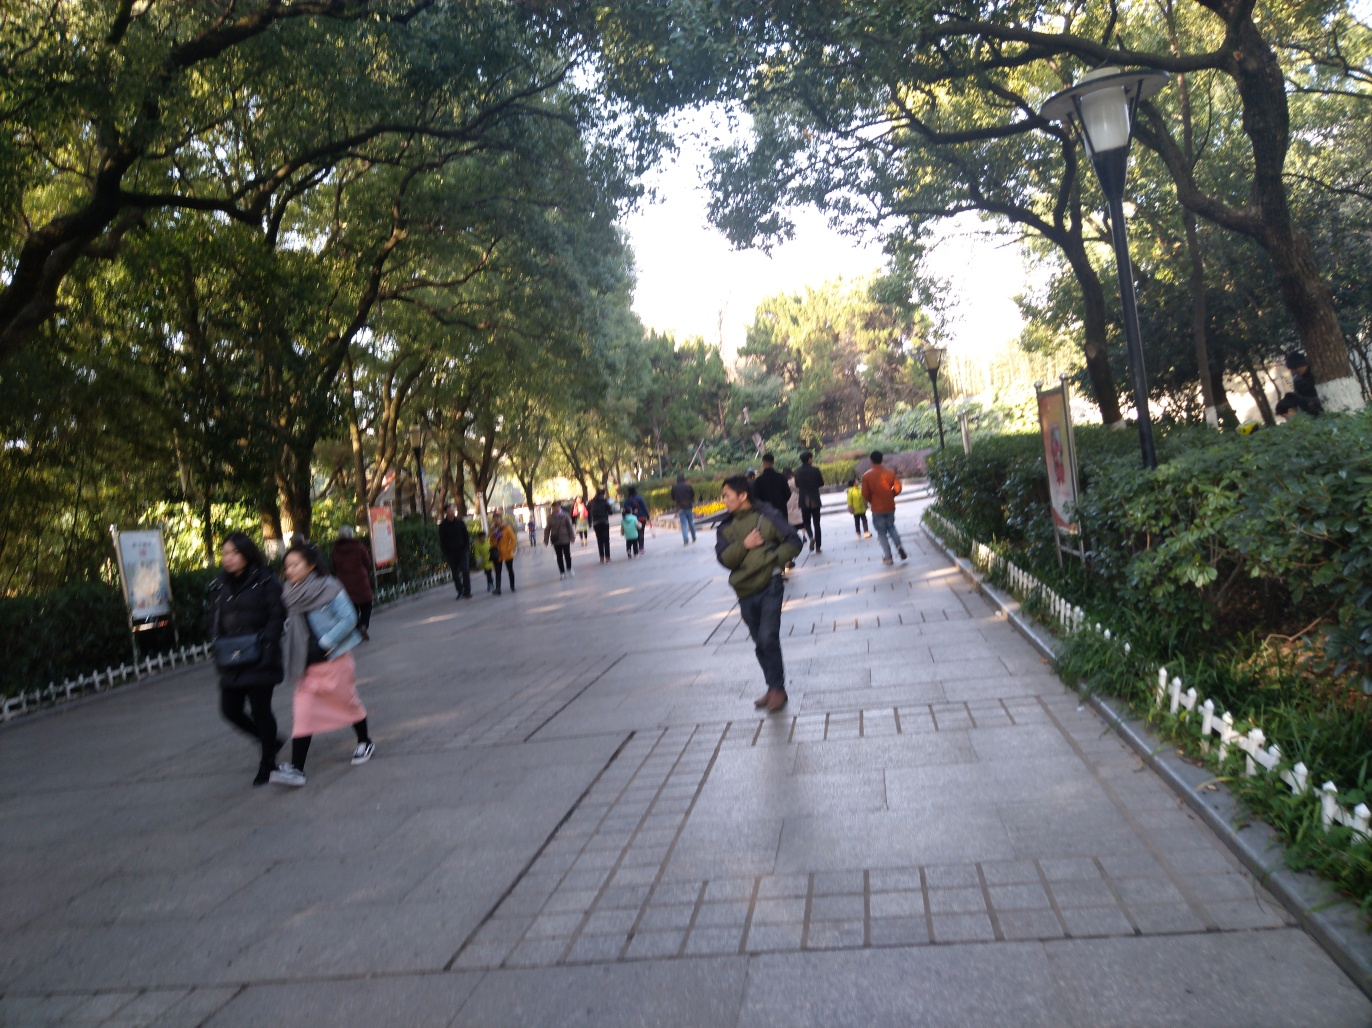What aspects could be improved in this photograph to enhance its visual appeal? To improve the visual appeal, the photographer should aim for a balanced and level composition by straightening the horizon line to give a sense of stability. Ensuring the camera is steady will help to avoid motion blur and bring the subjects into clear focus. Better timing to capture the natural flow of people in the space, along with mindful lighting techniques, could also enhance the overall quality and attractiveness of the photograph. 